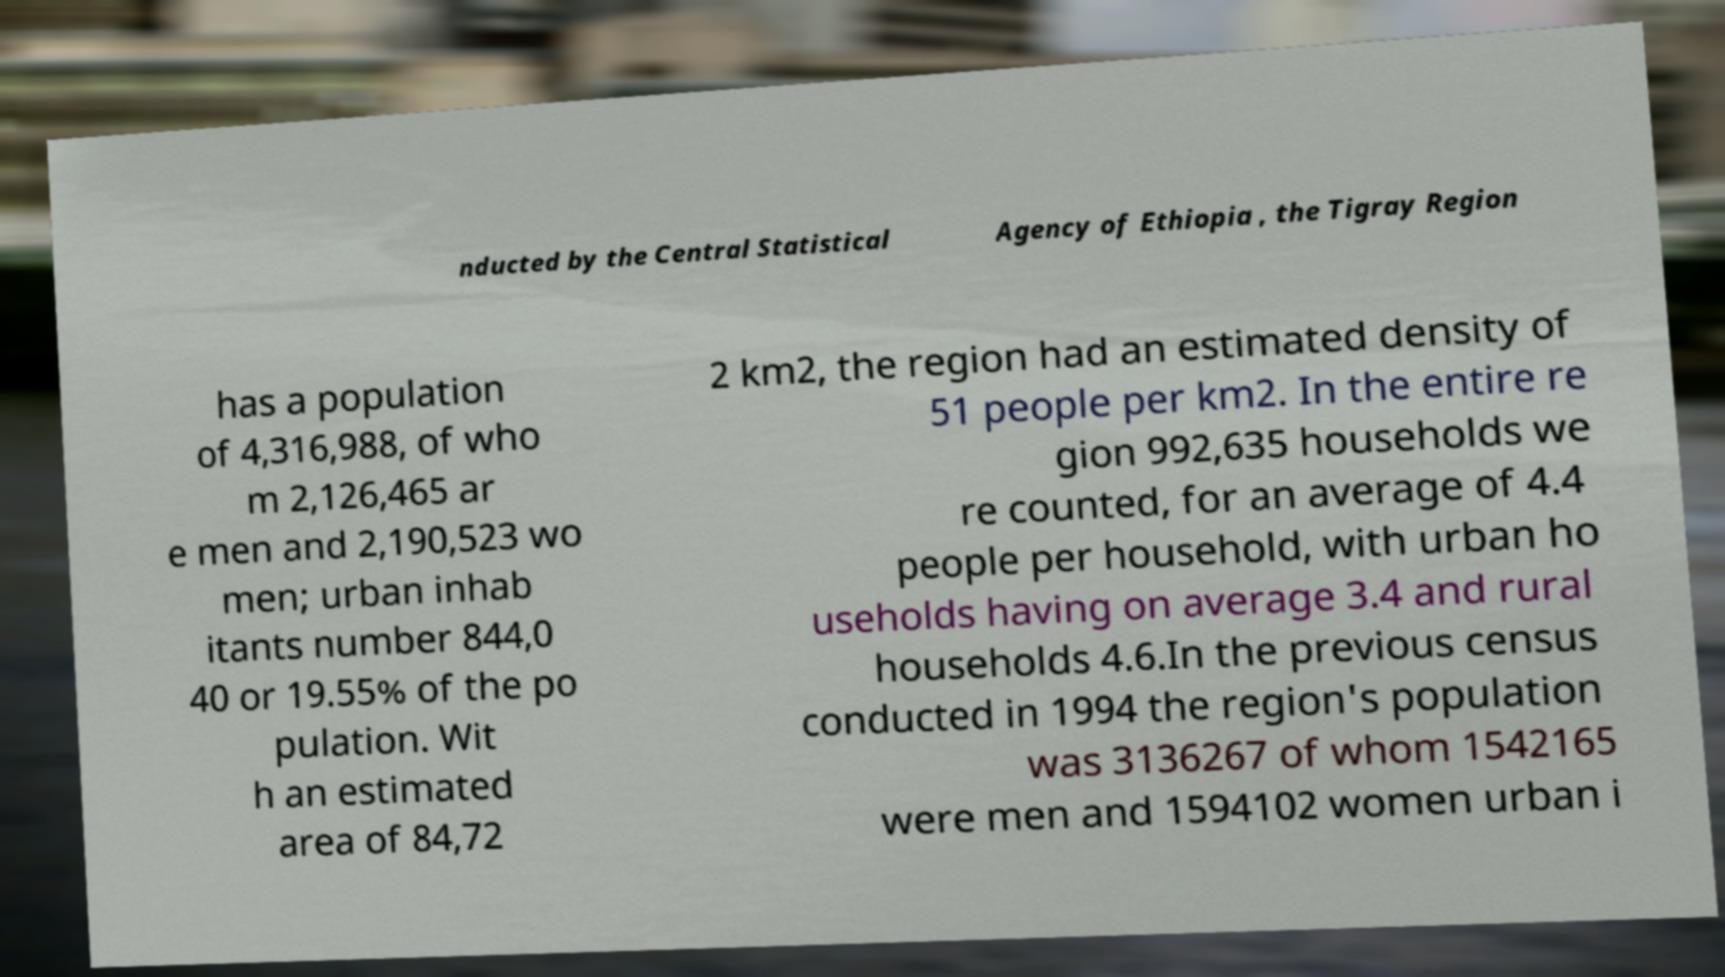Can you read and provide the text displayed in the image?This photo seems to have some interesting text. Can you extract and type it out for me? nducted by the Central Statistical Agency of Ethiopia , the Tigray Region has a population of 4,316,988, of who m 2,126,465 ar e men and 2,190,523 wo men; urban inhab itants number 844,0 40 or 19.55% of the po pulation. Wit h an estimated area of 84,72 2 km2, the region had an estimated density of 51 people per km2. In the entire re gion 992,635 households we re counted, for an average of 4.4 people per household, with urban ho useholds having on average 3.4 and rural households 4.6.In the previous census conducted in 1994 the region's population was 3136267 of whom 1542165 were men and 1594102 women urban i 